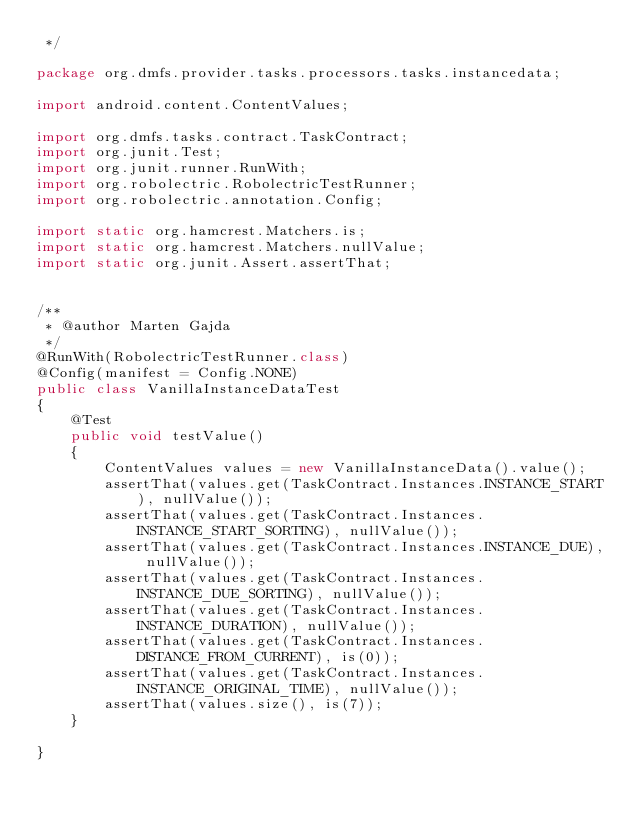<code> <loc_0><loc_0><loc_500><loc_500><_Java_> */

package org.dmfs.provider.tasks.processors.tasks.instancedata;

import android.content.ContentValues;

import org.dmfs.tasks.contract.TaskContract;
import org.junit.Test;
import org.junit.runner.RunWith;
import org.robolectric.RobolectricTestRunner;
import org.robolectric.annotation.Config;

import static org.hamcrest.Matchers.is;
import static org.hamcrest.Matchers.nullValue;
import static org.junit.Assert.assertThat;


/**
 * @author Marten Gajda
 */
@RunWith(RobolectricTestRunner.class)
@Config(manifest = Config.NONE)
public class VanillaInstanceDataTest
{
    @Test
    public void testValue()
    {
        ContentValues values = new VanillaInstanceData().value();
        assertThat(values.get(TaskContract.Instances.INSTANCE_START), nullValue());
        assertThat(values.get(TaskContract.Instances.INSTANCE_START_SORTING), nullValue());
        assertThat(values.get(TaskContract.Instances.INSTANCE_DUE), nullValue());
        assertThat(values.get(TaskContract.Instances.INSTANCE_DUE_SORTING), nullValue());
        assertThat(values.get(TaskContract.Instances.INSTANCE_DURATION), nullValue());
        assertThat(values.get(TaskContract.Instances.DISTANCE_FROM_CURRENT), is(0));
        assertThat(values.get(TaskContract.Instances.INSTANCE_ORIGINAL_TIME), nullValue());
        assertThat(values.size(), is(7));
    }

}</code> 